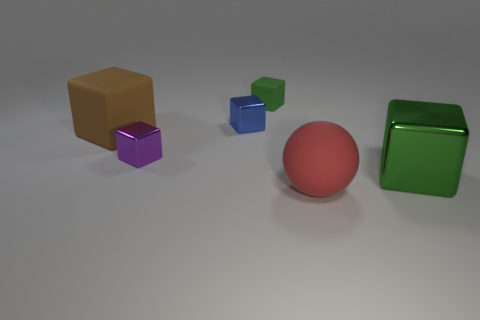What number of other objects are there of the same size as the rubber ball?
Ensure brevity in your answer.  2. What is the size of the other cube that is the same color as the tiny matte cube?
Ensure brevity in your answer.  Large. Is the shape of the object that is in front of the large green metal cube the same as  the big green metal thing?
Give a very brief answer. No. There is a small block behind the small blue thing; what is its material?
Keep it short and to the point. Rubber. There is a metal thing that is the same color as the tiny rubber thing; what shape is it?
Your answer should be very brief. Cube. Are there any large brown cubes that have the same material as the blue thing?
Give a very brief answer. No. What size is the blue metal block?
Ensure brevity in your answer.  Small. How many green things are either matte objects or rubber blocks?
Your response must be concise. 1. What number of other objects have the same shape as the red object?
Provide a succinct answer. 0. What number of green matte blocks have the same size as the purple metallic cube?
Give a very brief answer. 1. 